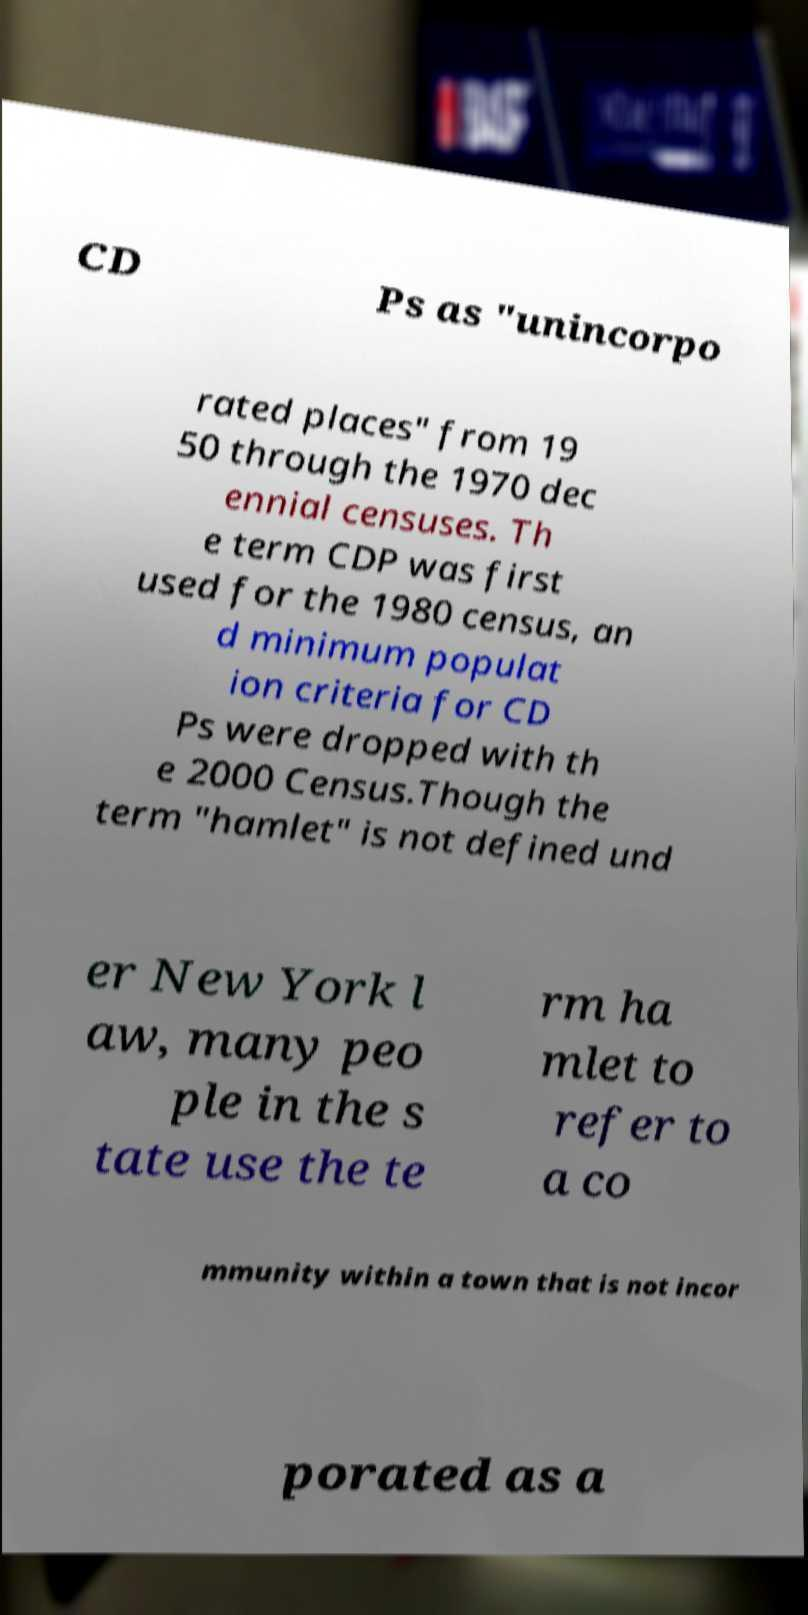Please read and relay the text visible in this image. What does it say? CD Ps as "unincorpo rated places" from 19 50 through the 1970 dec ennial censuses. Th e term CDP was first used for the 1980 census, an d minimum populat ion criteria for CD Ps were dropped with th e 2000 Census.Though the term "hamlet" is not defined und er New York l aw, many peo ple in the s tate use the te rm ha mlet to refer to a co mmunity within a town that is not incor porated as a 